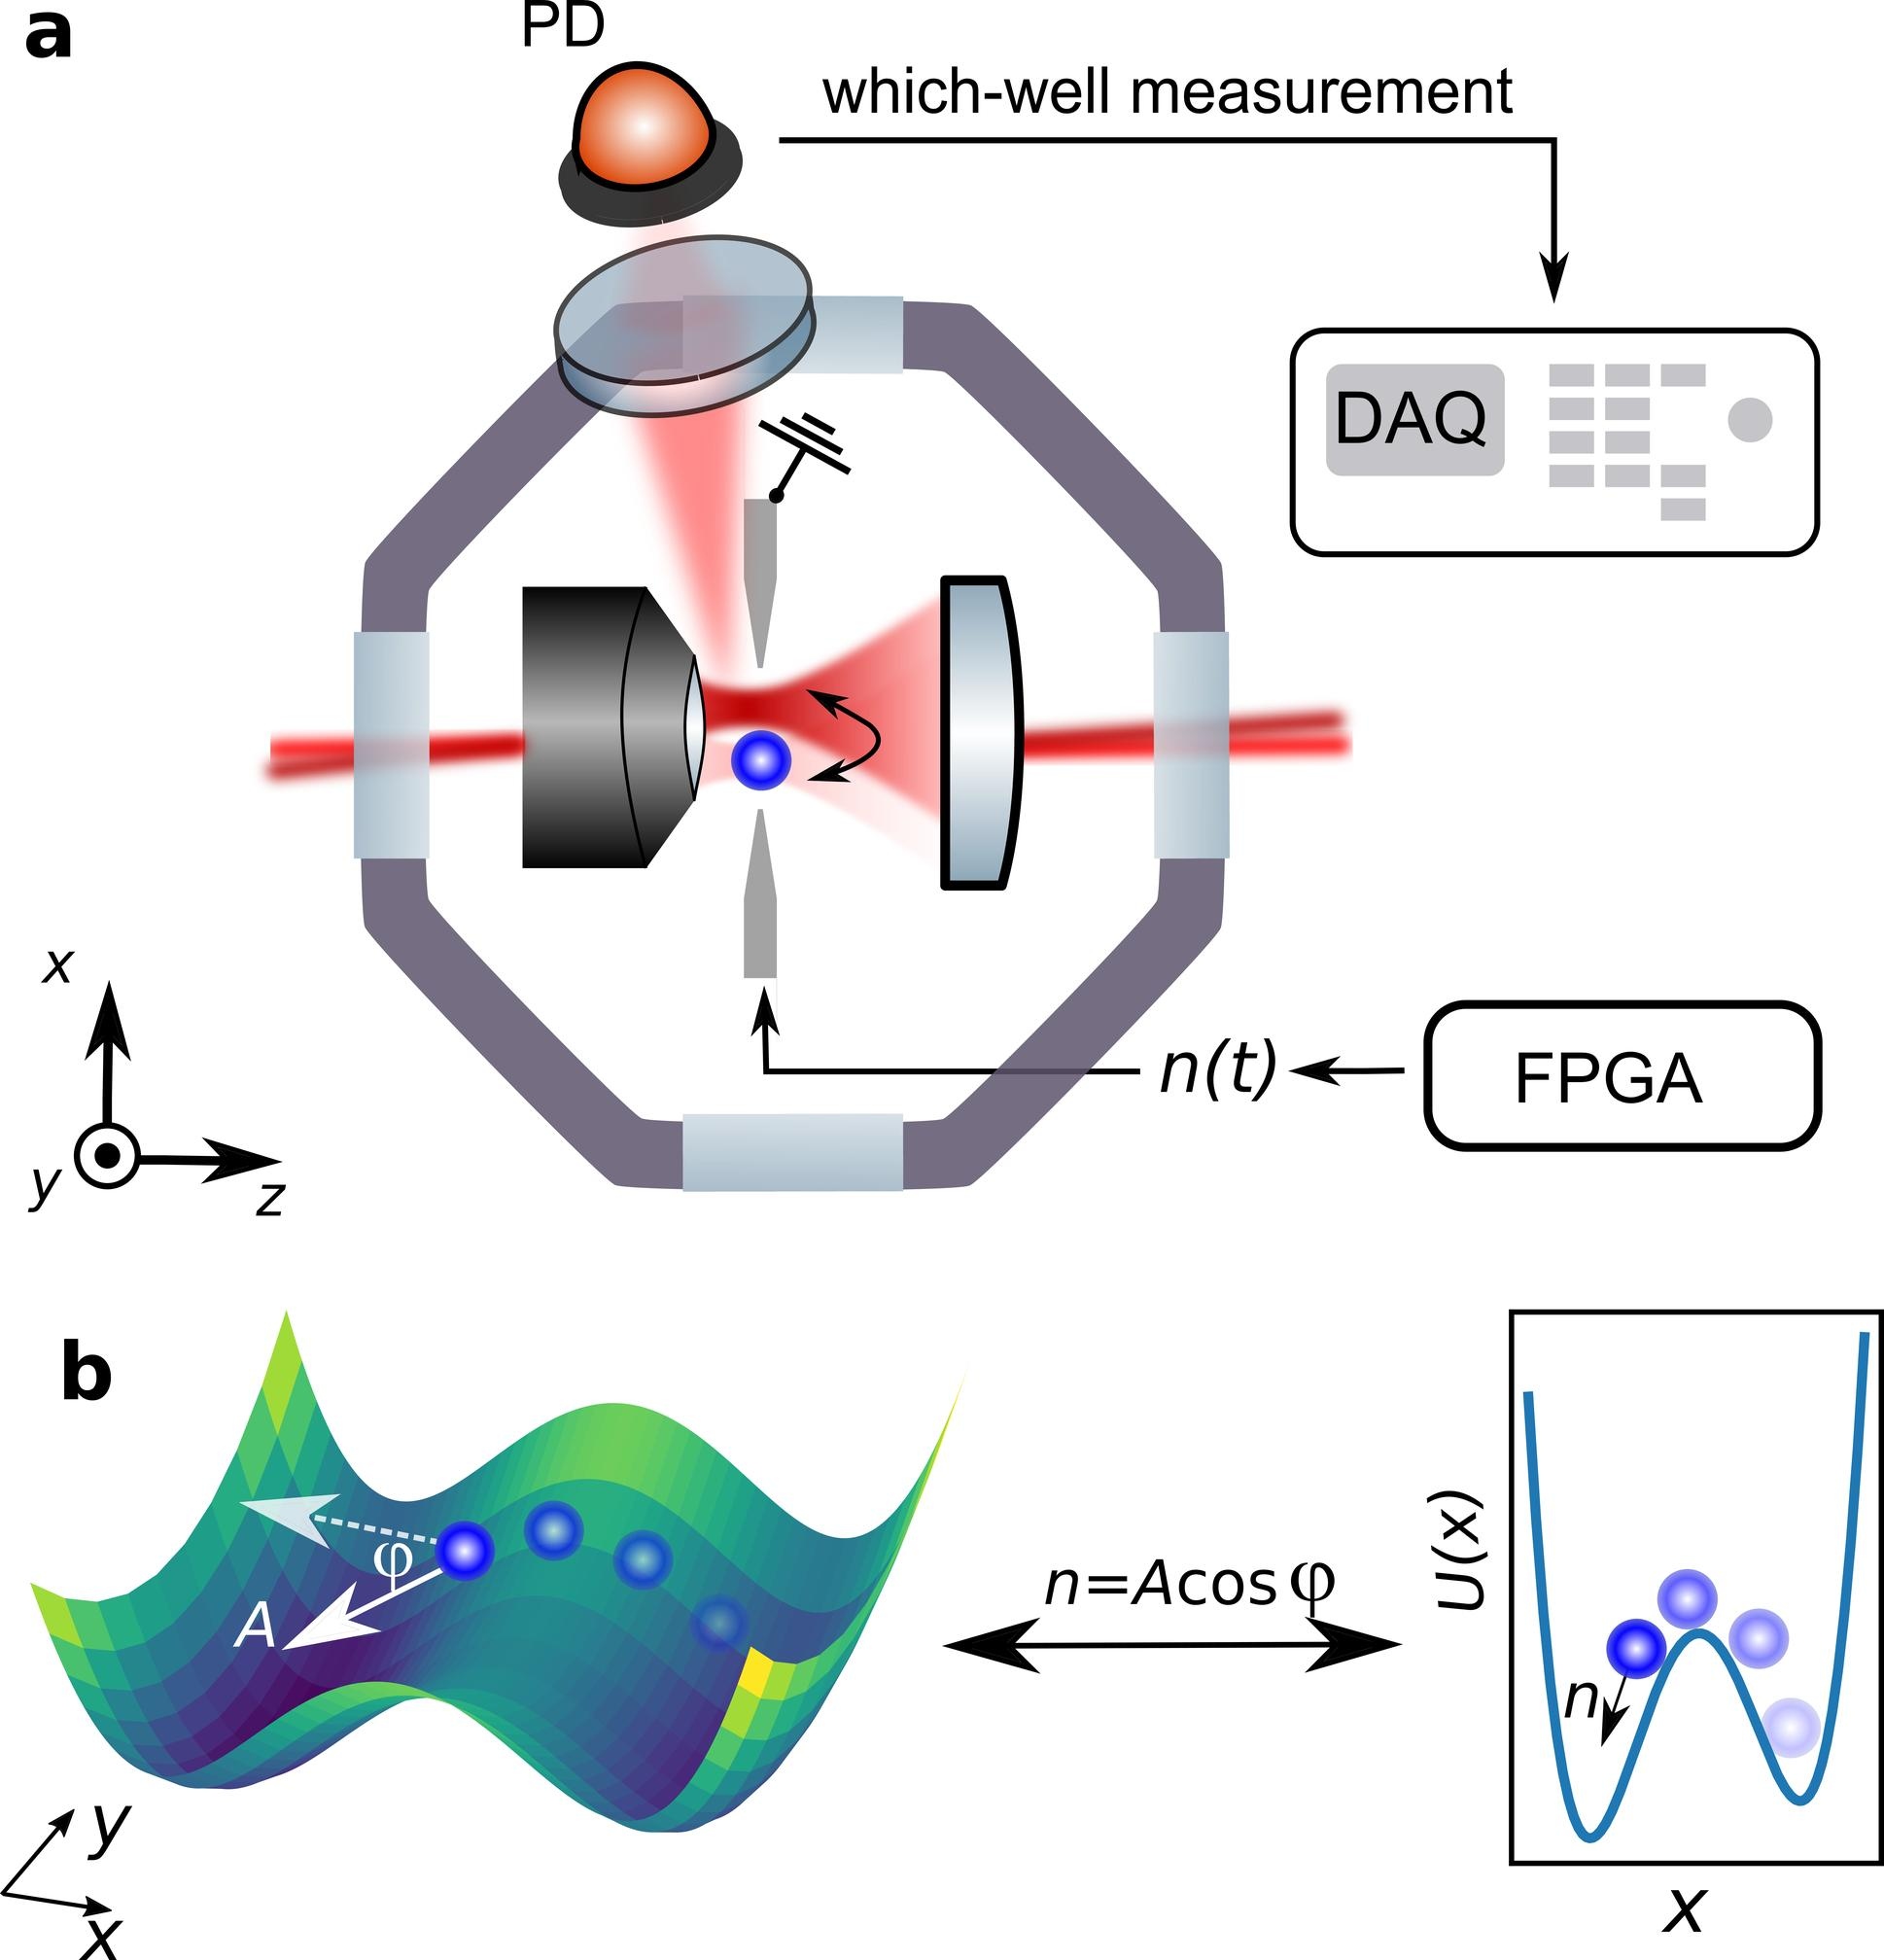Based on Figure b, what is the relationship between "n" and "φ"? A. n is directly proportional to φ. B. n is the amplitude of oscillation as a function of φ. C. n is a constant multiplied by the cosine of φ. D. n is the potential energy as a function of φ. The notation "n=Acos(φ)" in Figure b indicates that "n" is the product of some amplitude "A" and the cosine of "φ," showing that "n" varies as the cosine of "φ." Therefore, the correct answer is C. 